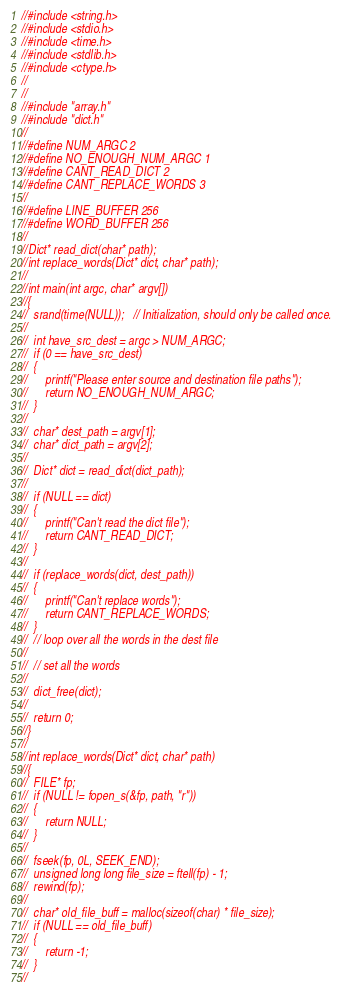<code> <loc_0><loc_0><loc_500><loc_500><_C_>//#include <string.h>
//#include <stdio.h>
//#include <time.h>
//#include <stdlib.h>
//#include <ctype.h>
//
//
//#include "array.h"
//#include "dict.h"
//
//#define NUM_ARGC 2
//#define NO_ENOUGH_NUM_ARGC 1
//#define CANT_READ_DICT 2
//#define CANT_REPLACE_WORDS 3
//
//#define LINE_BUFFER 256
//#define WORD_BUFFER 256
//
//Dict* read_dict(char* path);
//int replace_words(Dict* dict, char* path);
//
//int main(int argc, char* argv[])
//{
//	srand(time(NULL));   // Initialization, should only be called once.
//
//	int have_src_dest = argc > NUM_ARGC;
//	if (0 == have_src_dest)
//	{
//		printf("Please enter source and destination file paths");
//		return NO_ENOUGH_NUM_ARGC;
//	}
//
//	char* dest_path = argv[1];
//	char* dict_path = argv[2];
//
//	Dict* dict = read_dict(dict_path);
//
//	if (NULL == dict)
//	{
//		printf("Can't read the dict file");
//		return CANT_READ_DICT;
//	}
//
//	if (replace_words(dict, dest_path))
//	{
//		printf("Can't replace words");
//		return CANT_REPLACE_WORDS;
//	}
//	// loop over all the words in the dest file
//
//	// set all the words
//
//	dict_free(dict);
//
//	return 0;
//}
//
//int replace_words(Dict* dict, char* path)
//{
//	FILE* fp;
//	if (NULL != fopen_s(&fp, path, "r"))
//	{
//		return NULL;
//	}
//
//	fseek(fp, 0L, SEEK_END);
//	unsigned long long file_size = ftell(fp) - 1;
//	rewind(fp);
//
//	char* old_file_buff = malloc(sizeof(char) * file_size);
//	if (NULL == old_file_buff)
//	{
//		return -1;
//	}
//</code> 